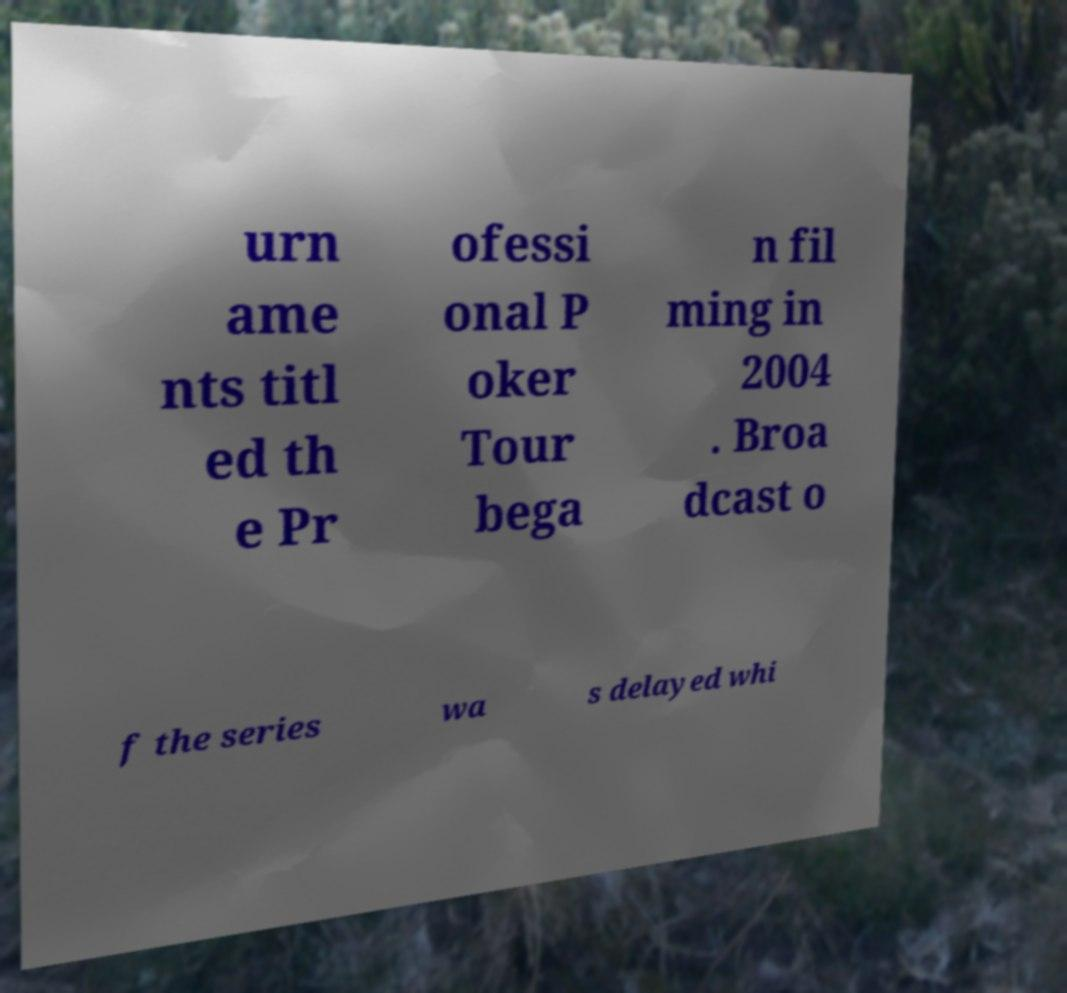Please read and relay the text visible in this image. What does it say? urn ame nts titl ed th e Pr ofessi onal P oker Tour bega n fil ming in 2004 . Broa dcast o f the series wa s delayed whi 